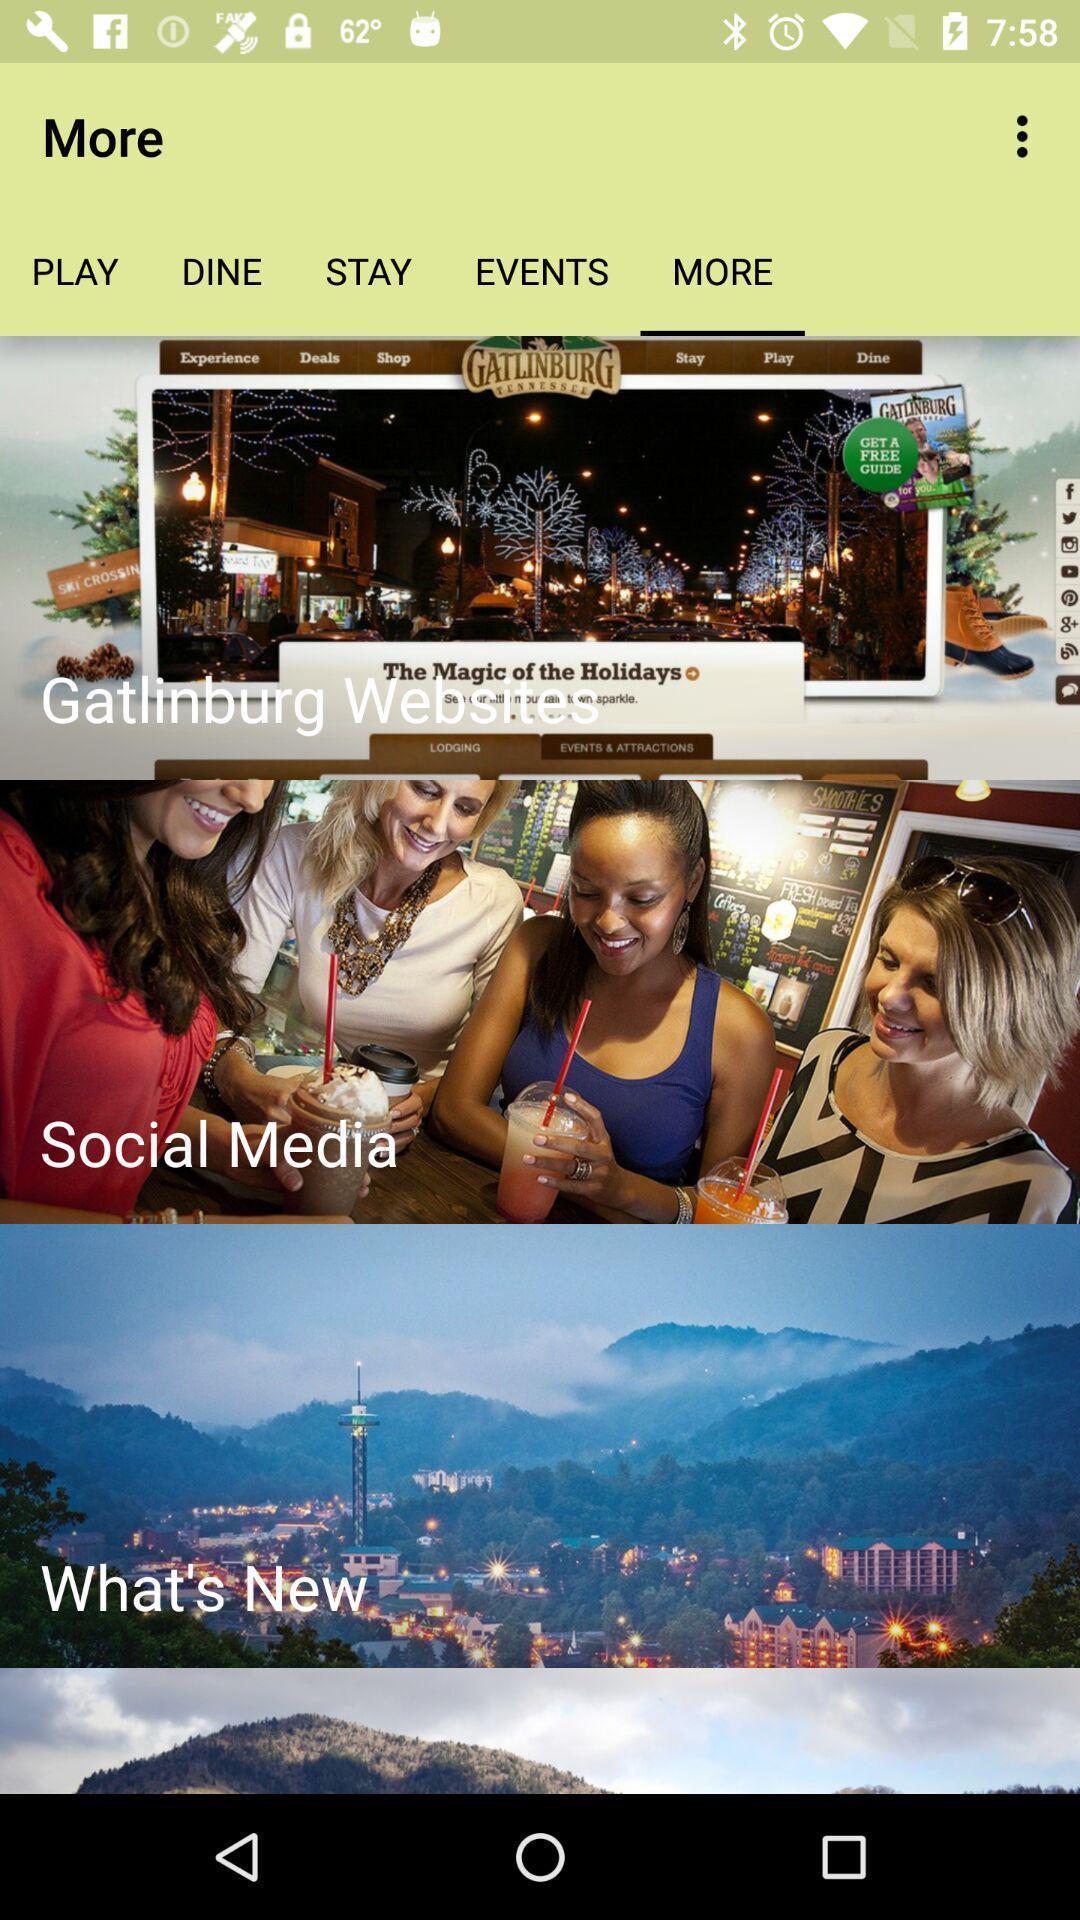What can you discern from this picture? Various options in more tab of a tourist app. 